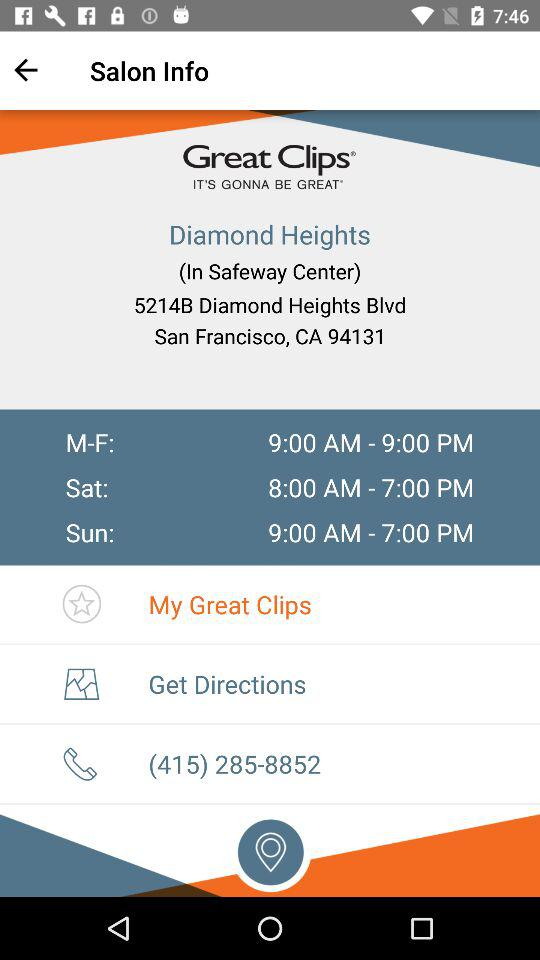What are the opening hours from Monday to Friday? The opening hours are from 9:00 AM to 9:00 PM. 